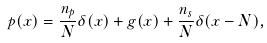<formula> <loc_0><loc_0><loc_500><loc_500>p ( x ) = \frac { n _ { p } } N \delta ( x ) + g ( x ) + \frac { n _ { s } } N \delta ( x - N ) ,</formula> 